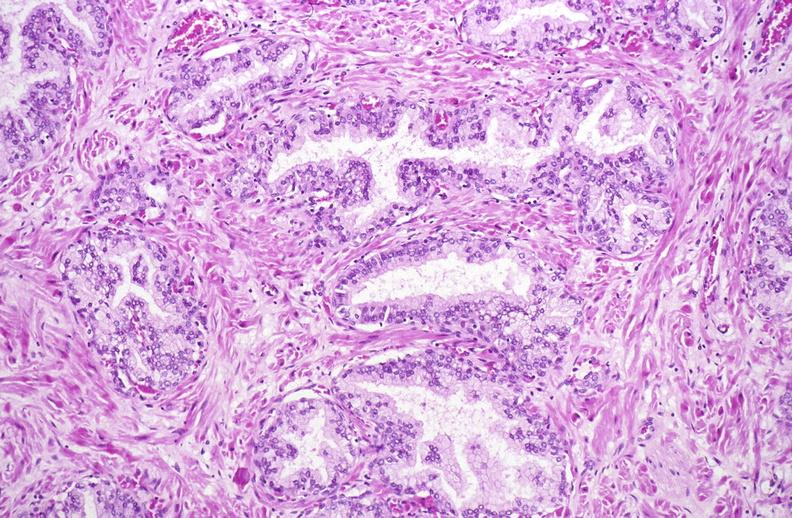what does this image show?
Answer the question using a single word or phrase. Normal prostate 